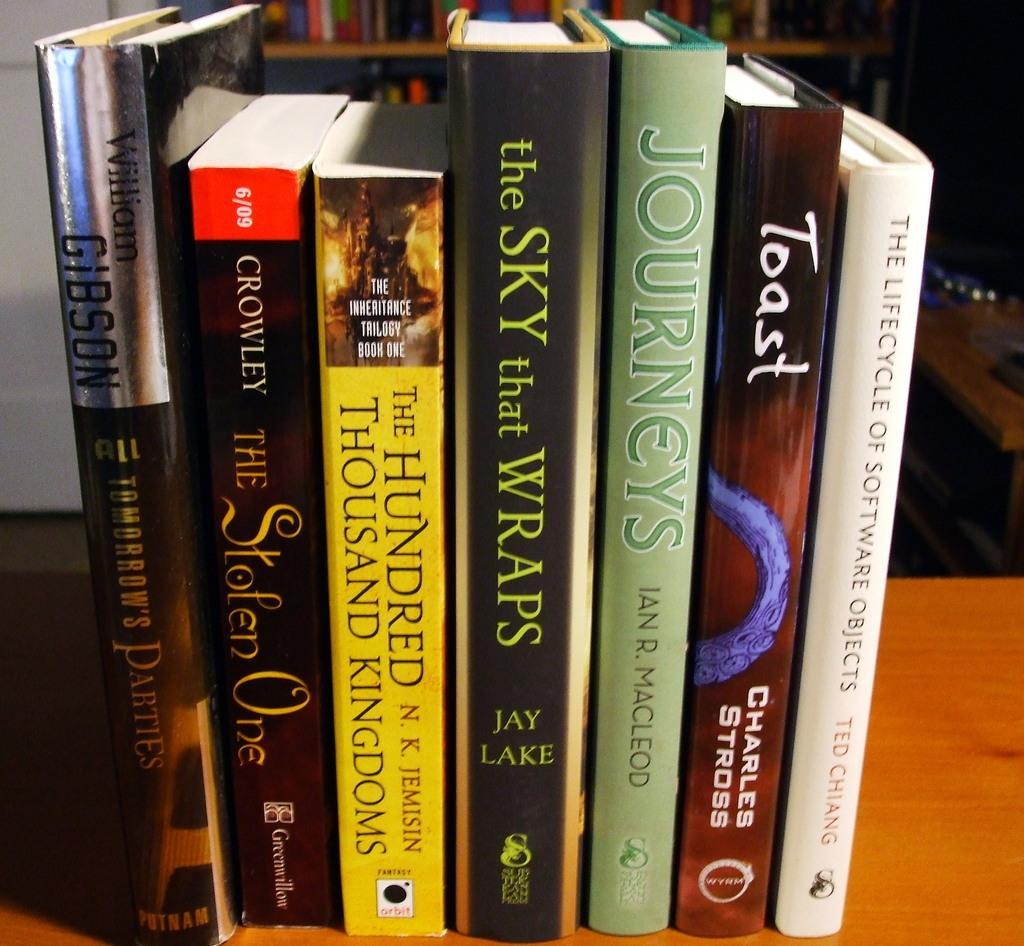In one or two sentences, can you explain what this image depicts? In this image we can see books on the table. In the background of the image there is a bookshelf with books. There is a wall. To the right side of the image there is a table. 